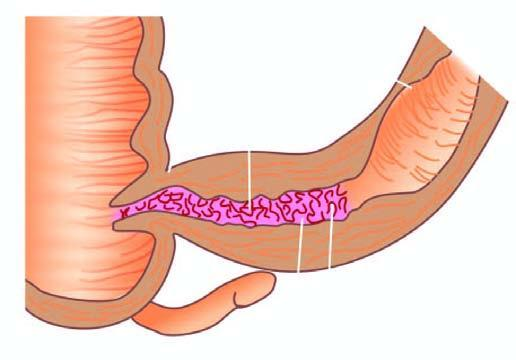what is shown in longitudinal section along with a segment in cross section?
Answer the question using a single word or phrase. Specimen of small intestine 